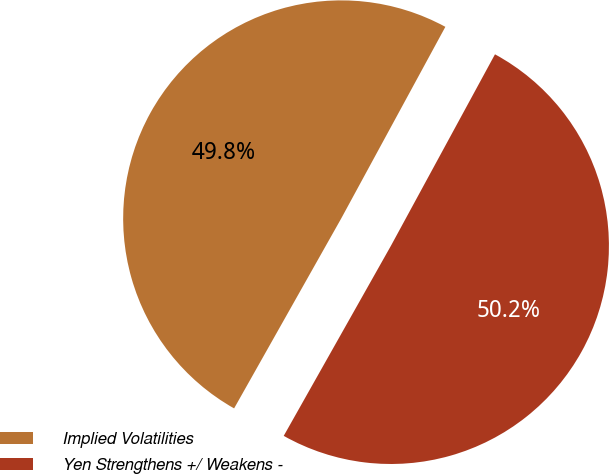Convert chart. <chart><loc_0><loc_0><loc_500><loc_500><pie_chart><fcel>Implied Volatilities<fcel>Yen Strengthens +/ Weakens -<nl><fcel>49.75%<fcel>50.25%<nl></chart> 